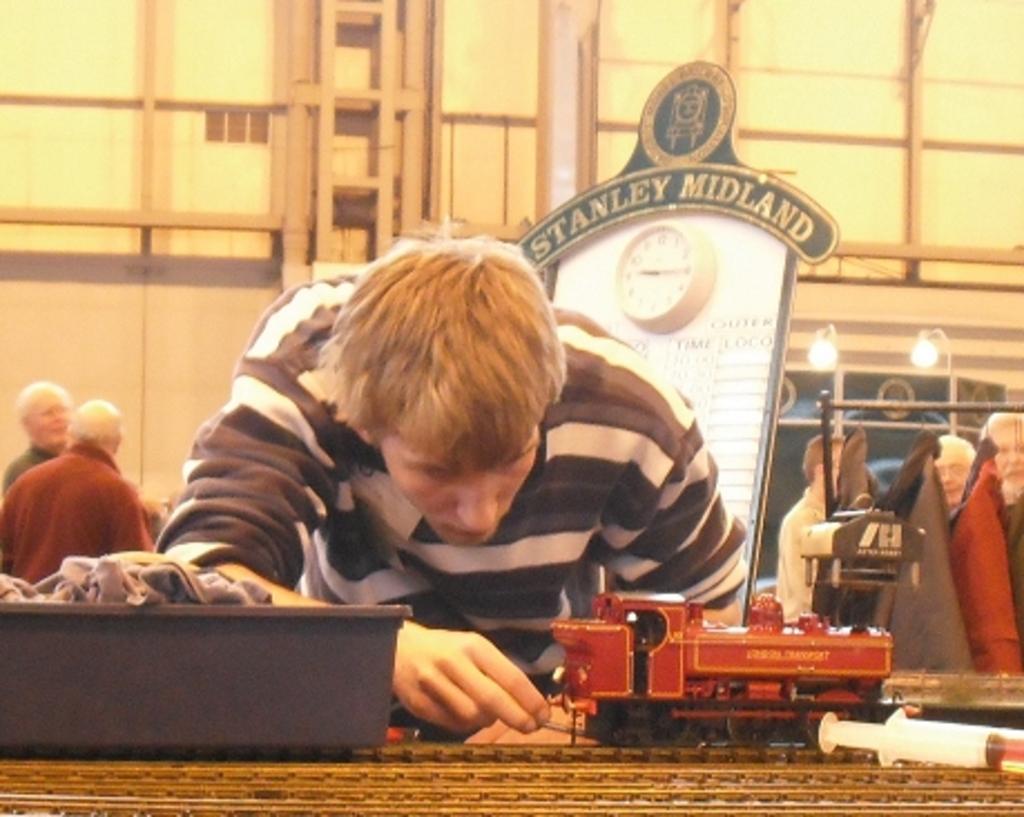Could you give a brief overview of what you see in this image? In this image, we can see a boy and there is a toy train, in the background, we can see a board and there are some people standing, we can see the wall. 